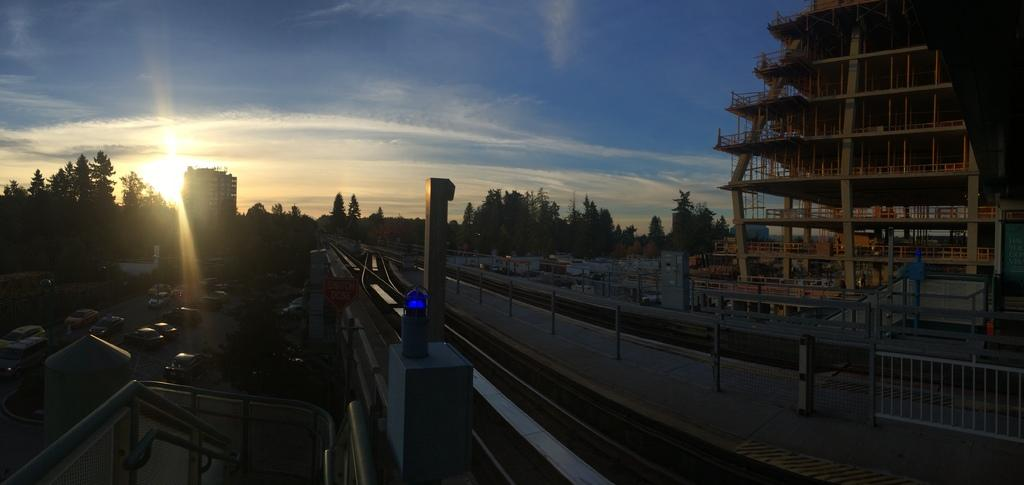What type of vehicles are on the left side of the image? There are cars on the left side of the image. What structures can be seen on the right side of the image? There are buildings on the right side of the image. What type of vegetation is in the center of the image? There are trees in the center of the image. What time does the flight take off in the image? There is no flight present in the image, so it is not possible to determine the time of departure. 